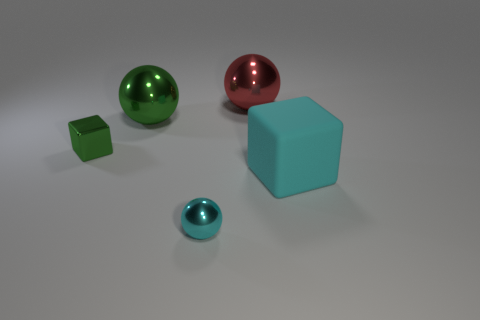Add 3 purple matte spheres. How many objects exist? 8 Subtract all cubes. How many objects are left? 3 Subtract 0 blue balls. How many objects are left? 5 Subtract all large objects. Subtract all cyan metal things. How many objects are left? 1 Add 3 large cyan matte things. How many large cyan matte things are left? 4 Add 1 metallic cubes. How many metallic cubes exist? 2 